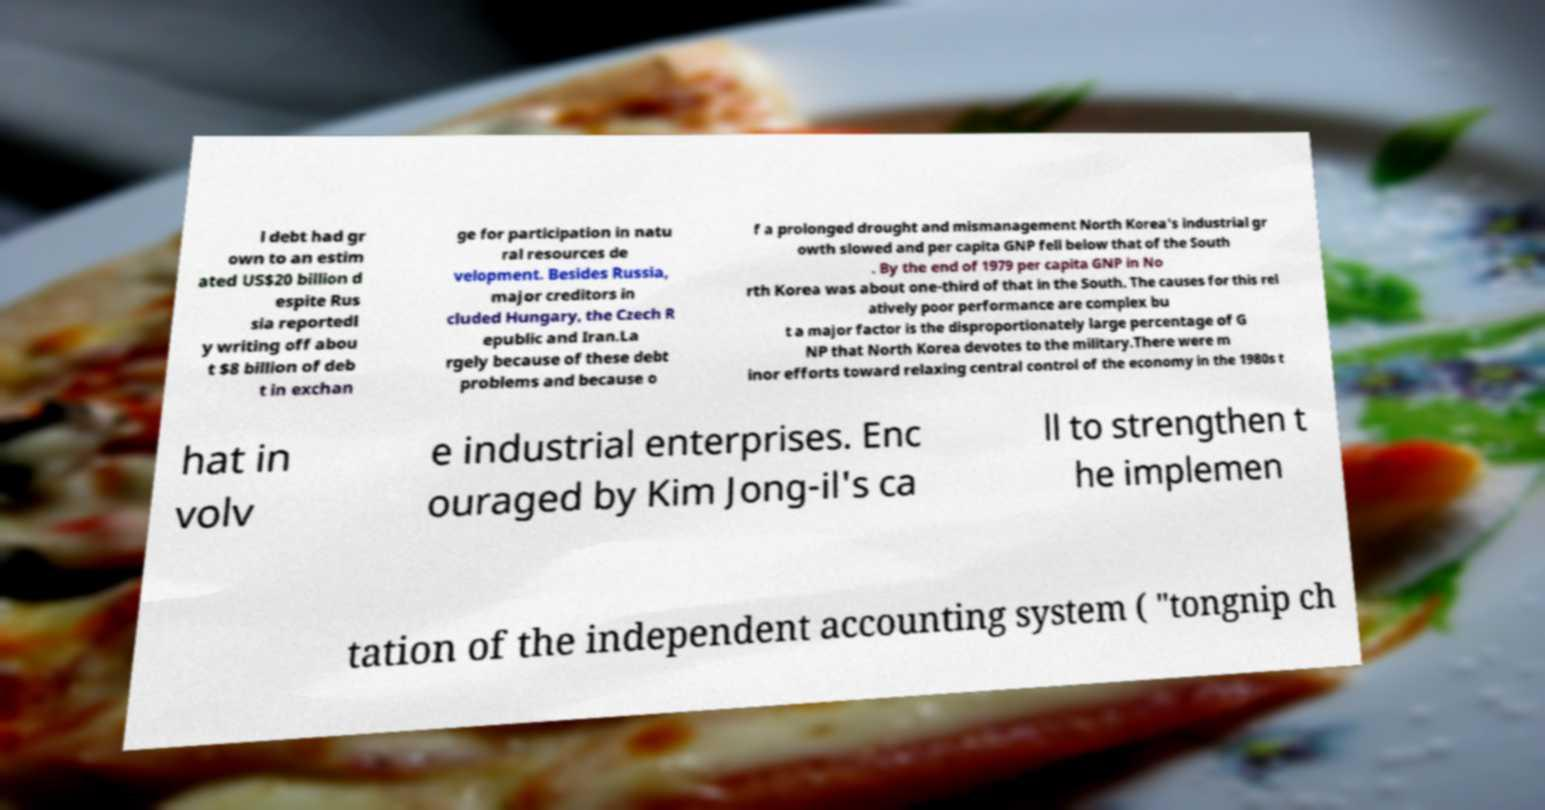Can you accurately transcribe the text from the provided image for me? l debt had gr own to an estim ated US$20 billion d espite Rus sia reportedl y writing off abou t $8 billion of deb t in exchan ge for participation in natu ral resources de velopment. Besides Russia, major creditors in cluded Hungary, the Czech R epublic and Iran.La rgely because of these debt problems and because o f a prolonged drought and mismanagement North Korea's industrial gr owth slowed and per capita GNP fell below that of the South . By the end of 1979 per capita GNP in No rth Korea was about one-third of that in the South. The causes for this rel atively poor performance are complex bu t a major factor is the disproportionately large percentage of G NP that North Korea devotes to the military.There were m inor efforts toward relaxing central control of the economy in the 1980s t hat in volv e industrial enterprises. Enc ouraged by Kim Jong-il's ca ll to strengthen t he implemen tation of the independent accounting system ( "tongnip ch 